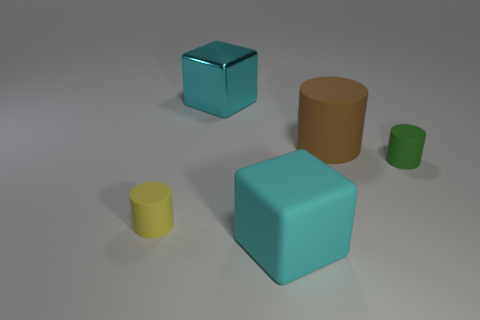Add 1 tiny green rubber cylinders. How many objects exist? 6 Subtract all small rubber cylinders. How many cylinders are left? 1 Subtract all cylinders. How many objects are left? 2 Add 5 brown things. How many brown things are left? 6 Add 2 big cyan shiny objects. How many big cyan shiny objects exist? 3 Subtract all brown cylinders. How many cylinders are left? 2 Subtract 0 cyan cylinders. How many objects are left? 5 Subtract 1 cylinders. How many cylinders are left? 2 Subtract all gray cylinders. Subtract all gray blocks. How many cylinders are left? 3 Subtract all small brown rubber spheres. Subtract all cyan matte objects. How many objects are left? 4 